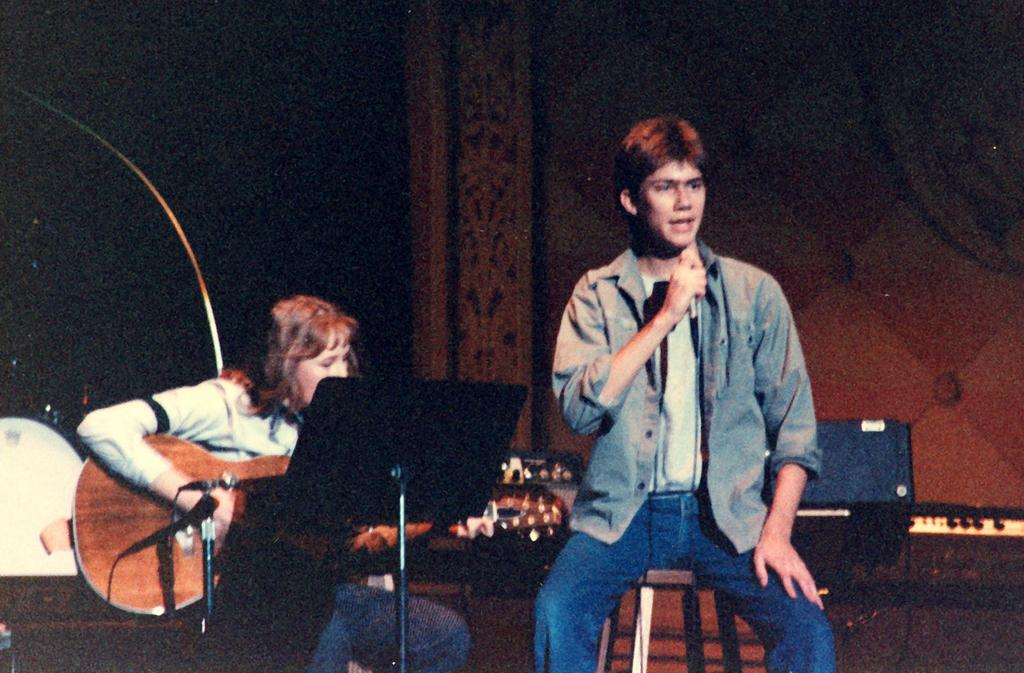How many people are in the image? There are two persons in the image. What are the two persons doing? Both persons are sitting. What objects are each person holding? One person is holding a microphone, and the other person is holding a guitar. What can be seen in the background of the image? There is a wall in the background of the image. Can you see a giraffe in the image? No, there is no giraffe present in the image. What type of machine is being used by the person holding the microphone? There is no machine visible in the image; the person is simply holding a microphone. 